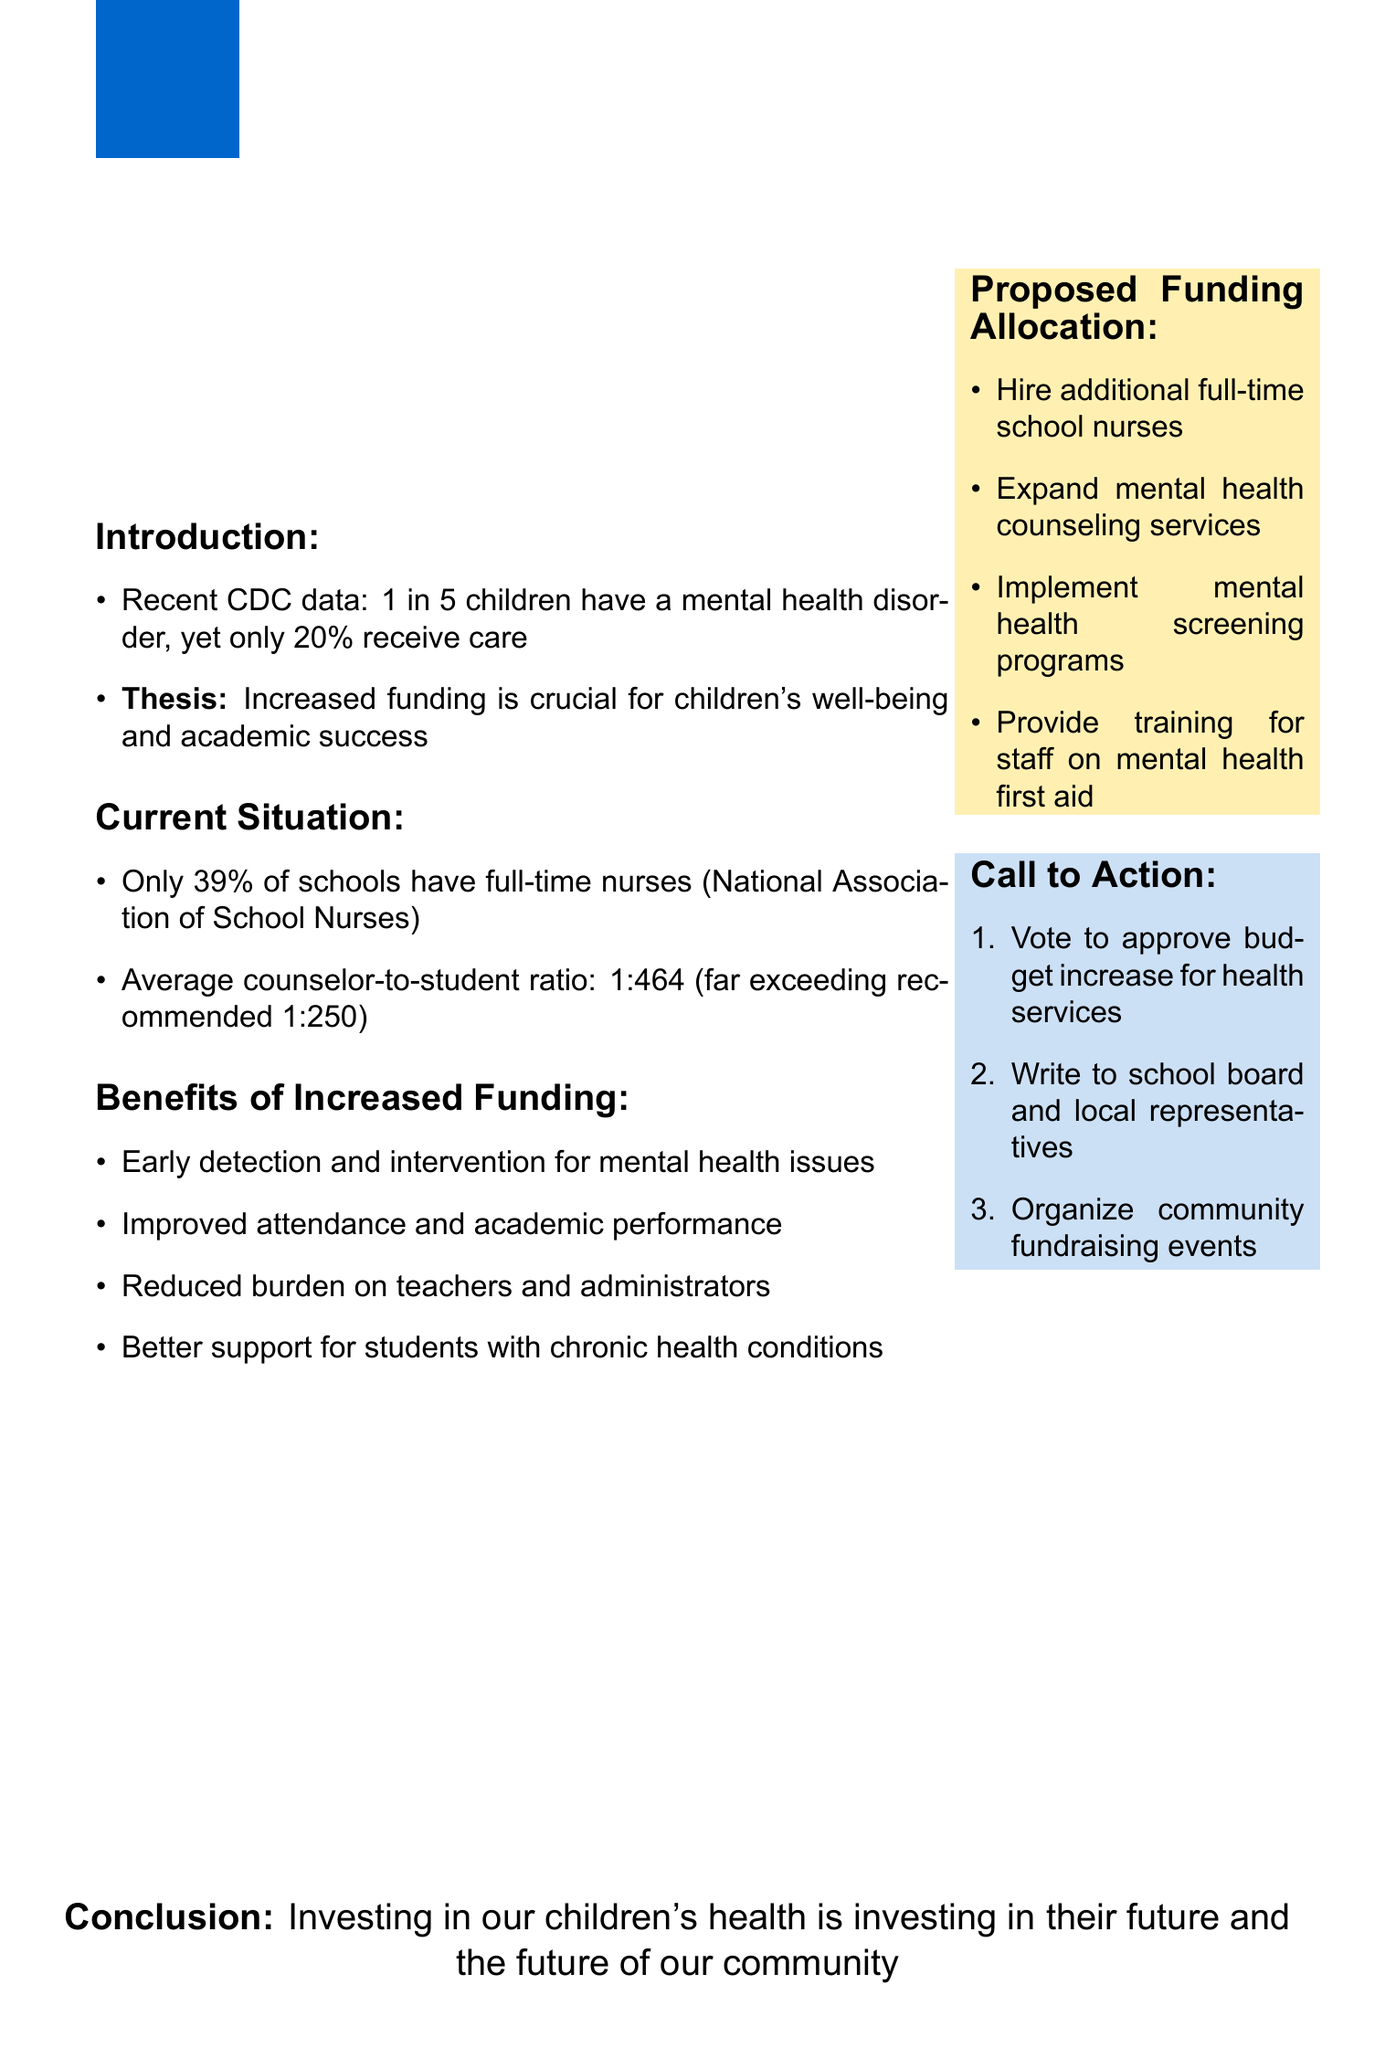What percentage of schools have full-time nurses? The document states that only 39% of schools have full-time nurses according to the National Association of School Nurses.
Answer: 39% What is the average counselor-to-student ratio mentioned? The document notes that the average counselor-to-student ratio is 1:464, exceeding the recommended 1:250.
Answer: 1:464 What is one benefit of increased funding for school nurses? The document lists several benefits, and one of them includes early detection and intervention for mental health issues.
Answer: Early detection and intervention for mental health issues What proposed action involves staffing? The document suggests hiring additional full-time school nurses as part of the proposed funding allocation.
Answer: Hire additional full-time school nurses What is one of the steps in the call to action? The document indicates several steps, including voting to approve a budget increase for health services.
Answer: Vote to approve budget increase for health services What fraction of children receive care for mental health disorders? The document mentions that only 20% of children with mental health disorders receive care.
Answer: 20% What is the conclusion of the document? The document concludes that investing in children's health is essential for their future and the community.
Answer: Investing in our children's health is investing in their future 